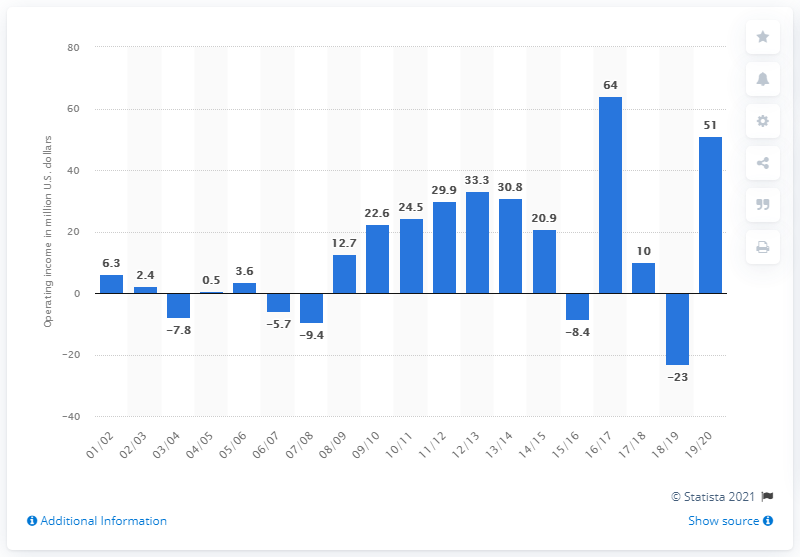Draw attention to some important aspects in this diagram. The operating income of the Oklahoma City Thunder for the 2019/20 season was $51 million. 